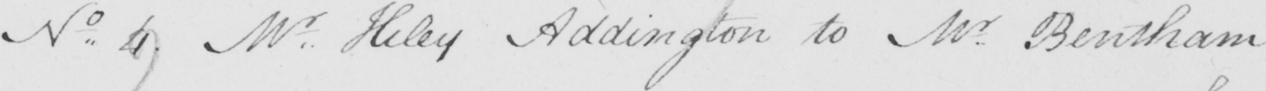What is written in this line of handwriting? Mr . Hiley Addington to Mr . Bentham  _ 